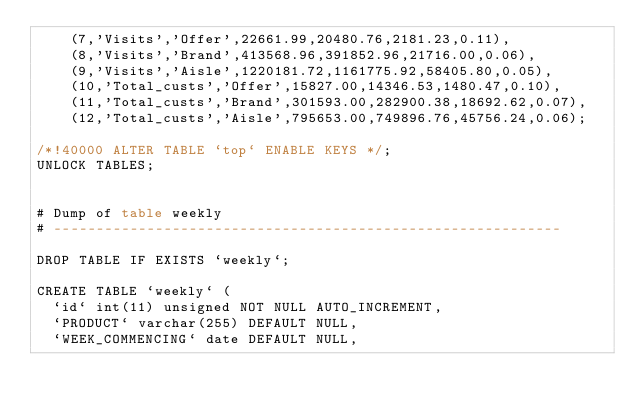<code> <loc_0><loc_0><loc_500><loc_500><_SQL_>	(7,'Visits','Offer',22661.99,20480.76,2181.23,0.11),
	(8,'Visits','Brand',413568.96,391852.96,21716.00,0.06),
	(9,'Visits','Aisle',1220181.72,1161775.92,58405.80,0.05),
	(10,'Total_custs','Offer',15827.00,14346.53,1480.47,0.10),
	(11,'Total_custs','Brand',301593.00,282900.38,18692.62,0.07),
	(12,'Total_custs','Aisle',795653.00,749896.76,45756.24,0.06);

/*!40000 ALTER TABLE `top` ENABLE KEYS */;
UNLOCK TABLES;


# Dump of table weekly
# ------------------------------------------------------------

DROP TABLE IF EXISTS `weekly`;

CREATE TABLE `weekly` (
  `id` int(11) unsigned NOT NULL AUTO_INCREMENT,
  `PRODUCT` varchar(255) DEFAULT NULL,
  `WEEK_COMMENCING` date DEFAULT NULL,</code> 